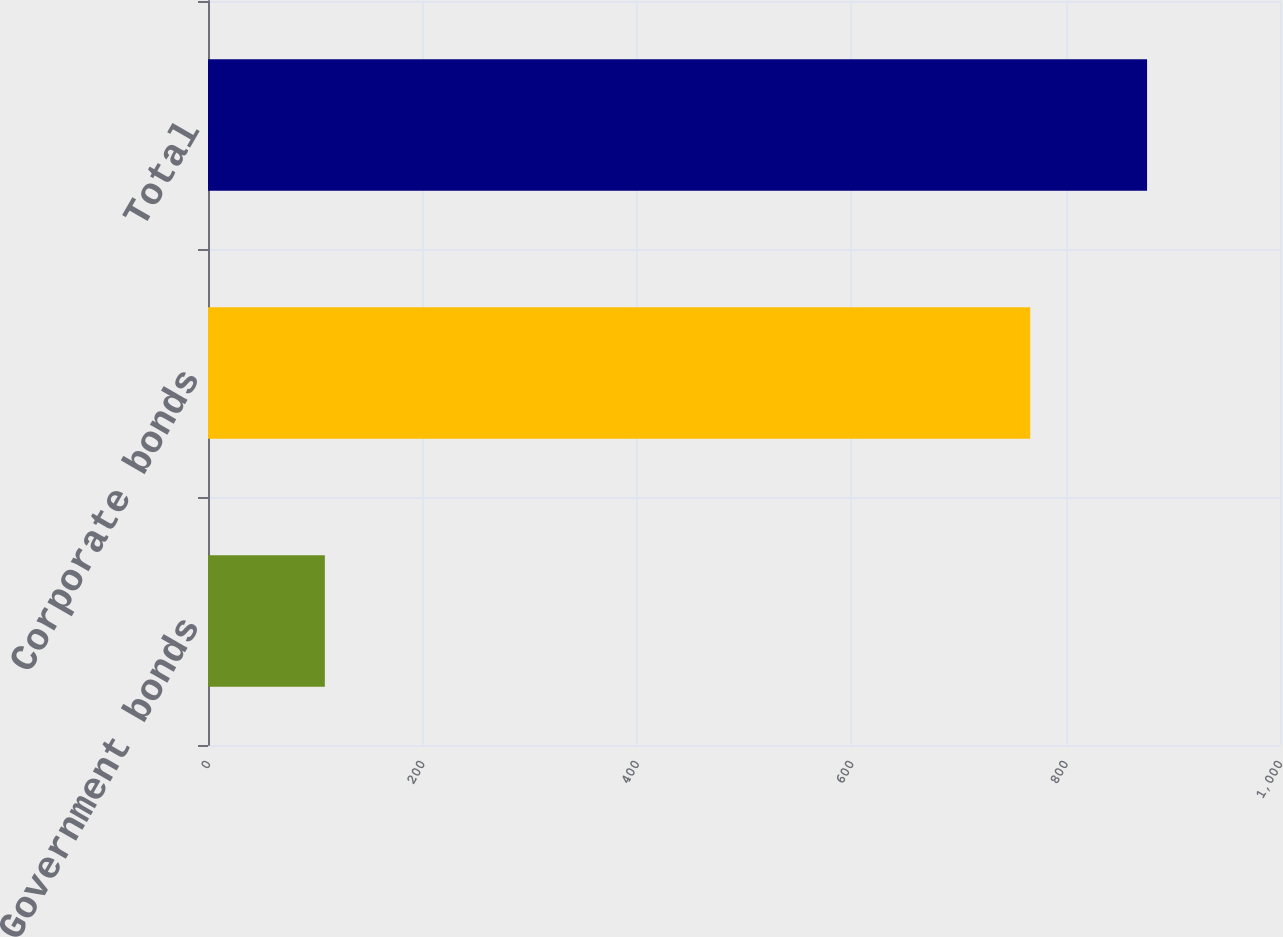<chart> <loc_0><loc_0><loc_500><loc_500><bar_chart><fcel>Government bonds<fcel>Corporate bonds<fcel>Total<nl><fcel>109<fcel>767<fcel>876<nl></chart> 